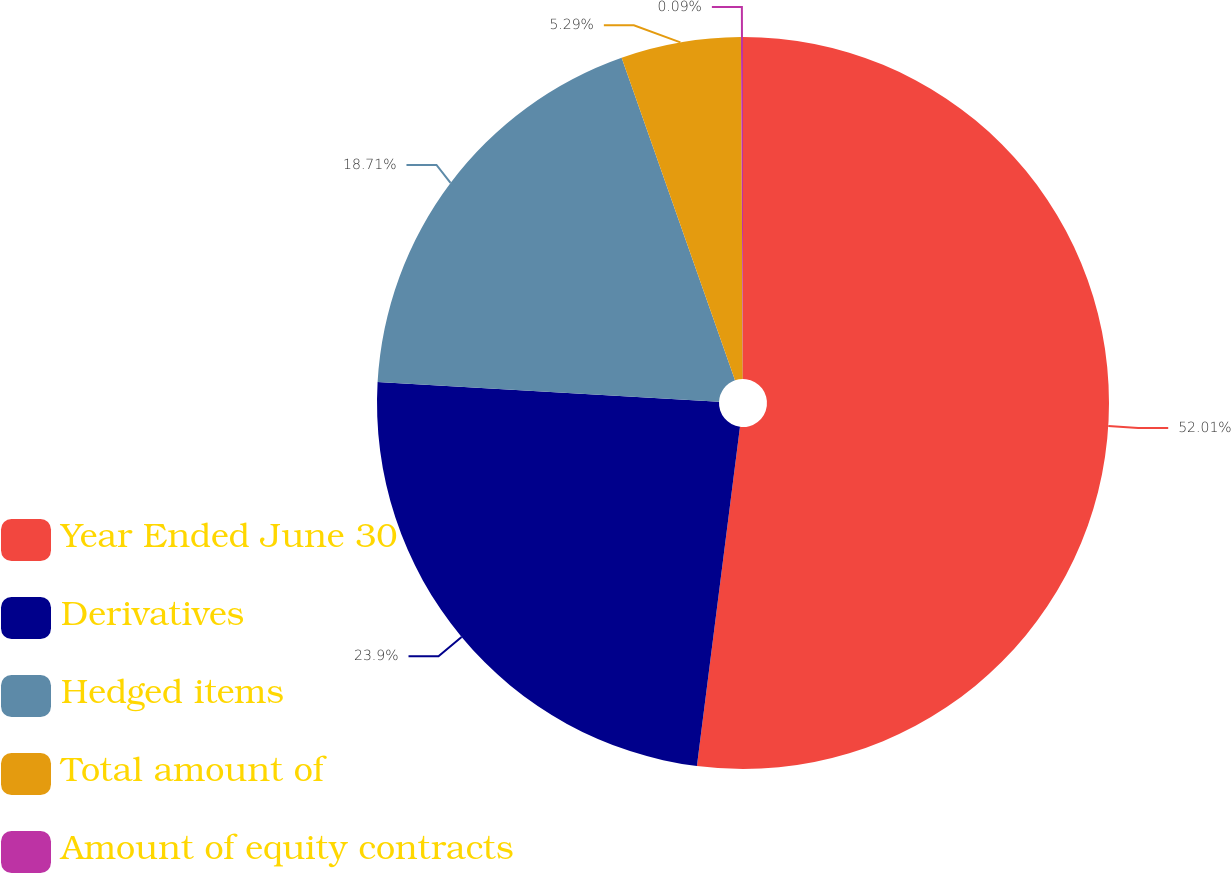<chart> <loc_0><loc_0><loc_500><loc_500><pie_chart><fcel>Year Ended June 30<fcel>Derivatives<fcel>Hedged items<fcel>Total amount of<fcel>Amount of equity contracts<nl><fcel>52.01%<fcel>23.9%<fcel>18.71%<fcel>5.29%<fcel>0.09%<nl></chart> 